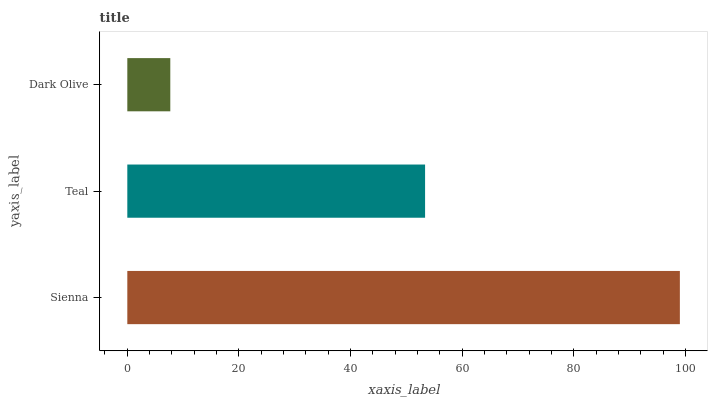Is Dark Olive the minimum?
Answer yes or no. Yes. Is Sienna the maximum?
Answer yes or no. Yes. Is Teal the minimum?
Answer yes or no. No. Is Teal the maximum?
Answer yes or no. No. Is Sienna greater than Teal?
Answer yes or no. Yes. Is Teal less than Sienna?
Answer yes or no. Yes. Is Teal greater than Sienna?
Answer yes or no. No. Is Sienna less than Teal?
Answer yes or no. No. Is Teal the high median?
Answer yes or no. Yes. Is Teal the low median?
Answer yes or no. Yes. Is Sienna the high median?
Answer yes or no. No. Is Dark Olive the low median?
Answer yes or no. No. 